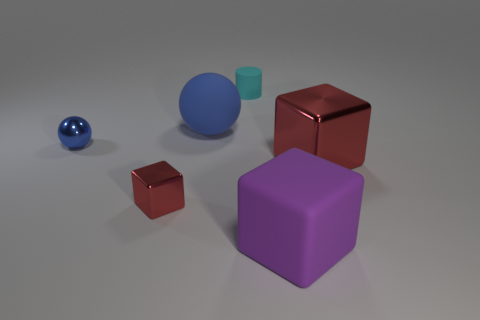How many red cubes must be subtracted to get 1 red cubes? 1 Subtract all red shiny cubes. How many cubes are left? 1 Subtract all yellow spheres. How many red blocks are left? 2 Subtract 1 blocks. How many blocks are left? 2 Add 2 small cyan rubber things. How many objects exist? 8 Add 5 rubber cylinders. How many rubber cylinders are left? 6 Add 4 big brown rubber things. How many big brown rubber things exist? 4 Subtract 0 red balls. How many objects are left? 6 Subtract all cylinders. How many objects are left? 5 Subtract all brown blocks. Subtract all blue spheres. How many blocks are left? 3 